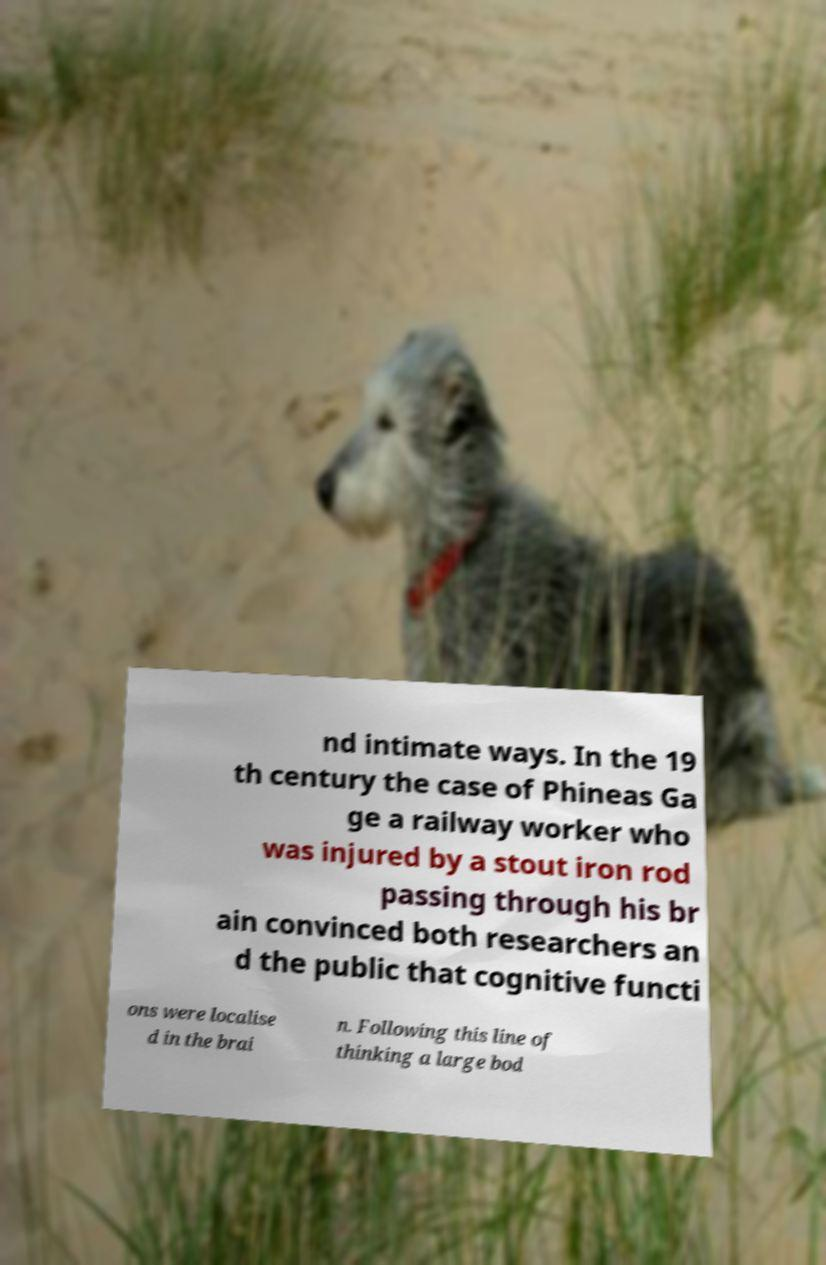What messages or text are displayed in this image? I need them in a readable, typed format. nd intimate ways. In the 19 th century the case of Phineas Ga ge a railway worker who was injured by a stout iron rod passing through his br ain convinced both researchers an d the public that cognitive functi ons were localise d in the brai n. Following this line of thinking a large bod 